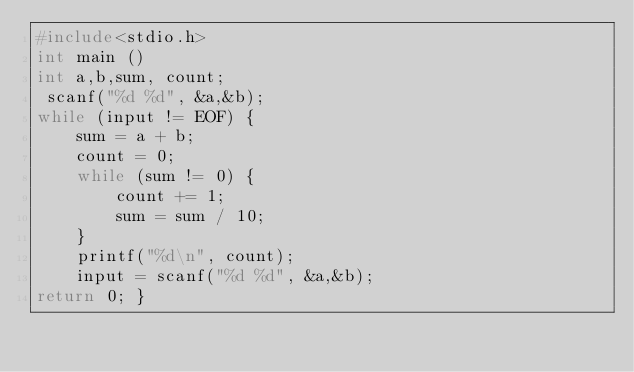Convert code to text. <code><loc_0><loc_0><loc_500><loc_500><_C_>#include<stdio.h>
int main ()
int a,b,sum, count;
 scanf("%d %d", &a,&b);
while (input != EOF) {
    sum = a + b;
    count = 0;
    while (sum != 0) {
        count += 1;
        sum = sum / 10;
    }
    printf("%d\n", count);
    input = scanf("%d %d", &a,&b);
return 0; }</code> 